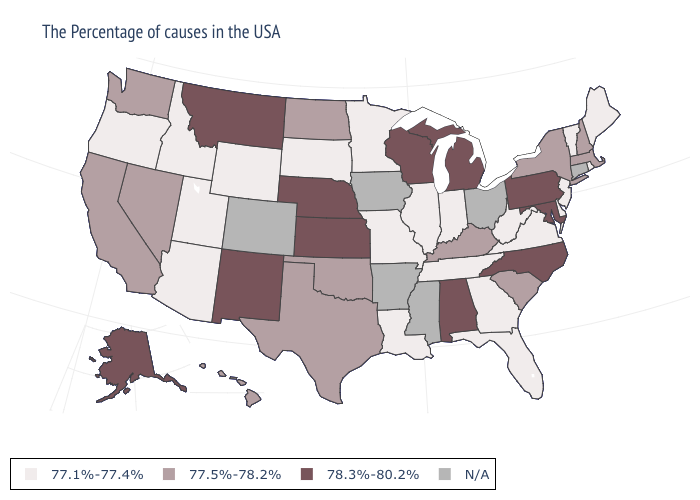What is the value of Delaware?
Write a very short answer. 77.1%-77.4%. Name the states that have a value in the range 78.3%-80.2%?
Be succinct. Maryland, Pennsylvania, North Carolina, Michigan, Alabama, Wisconsin, Kansas, Nebraska, New Mexico, Montana, Alaska. Which states have the lowest value in the USA?
Answer briefly. Maine, Rhode Island, Vermont, New Jersey, Delaware, Virginia, West Virginia, Florida, Georgia, Indiana, Tennessee, Illinois, Louisiana, Missouri, Minnesota, South Dakota, Wyoming, Utah, Arizona, Idaho, Oregon. Name the states that have a value in the range 78.3%-80.2%?
Keep it brief. Maryland, Pennsylvania, North Carolina, Michigan, Alabama, Wisconsin, Kansas, Nebraska, New Mexico, Montana, Alaska. Among the states that border Rhode Island , which have the highest value?
Quick response, please. Massachusetts. Among the states that border Delaware , which have the lowest value?
Answer briefly. New Jersey. What is the highest value in states that border Utah?
Keep it brief. 78.3%-80.2%. Name the states that have a value in the range N/A?
Write a very short answer. Connecticut, Ohio, Mississippi, Arkansas, Iowa, Colorado. What is the highest value in states that border Wisconsin?
Write a very short answer. 78.3%-80.2%. Name the states that have a value in the range N/A?
Give a very brief answer. Connecticut, Ohio, Mississippi, Arkansas, Iowa, Colorado. Which states have the lowest value in the South?
Quick response, please. Delaware, Virginia, West Virginia, Florida, Georgia, Tennessee, Louisiana. Does Kentucky have the lowest value in the USA?
Short answer required. No. Name the states that have a value in the range 78.3%-80.2%?
Write a very short answer. Maryland, Pennsylvania, North Carolina, Michigan, Alabama, Wisconsin, Kansas, Nebraska, New Mexico, Montana, Alaska. Does the map have missing data?
Keep it brief. Yes. 